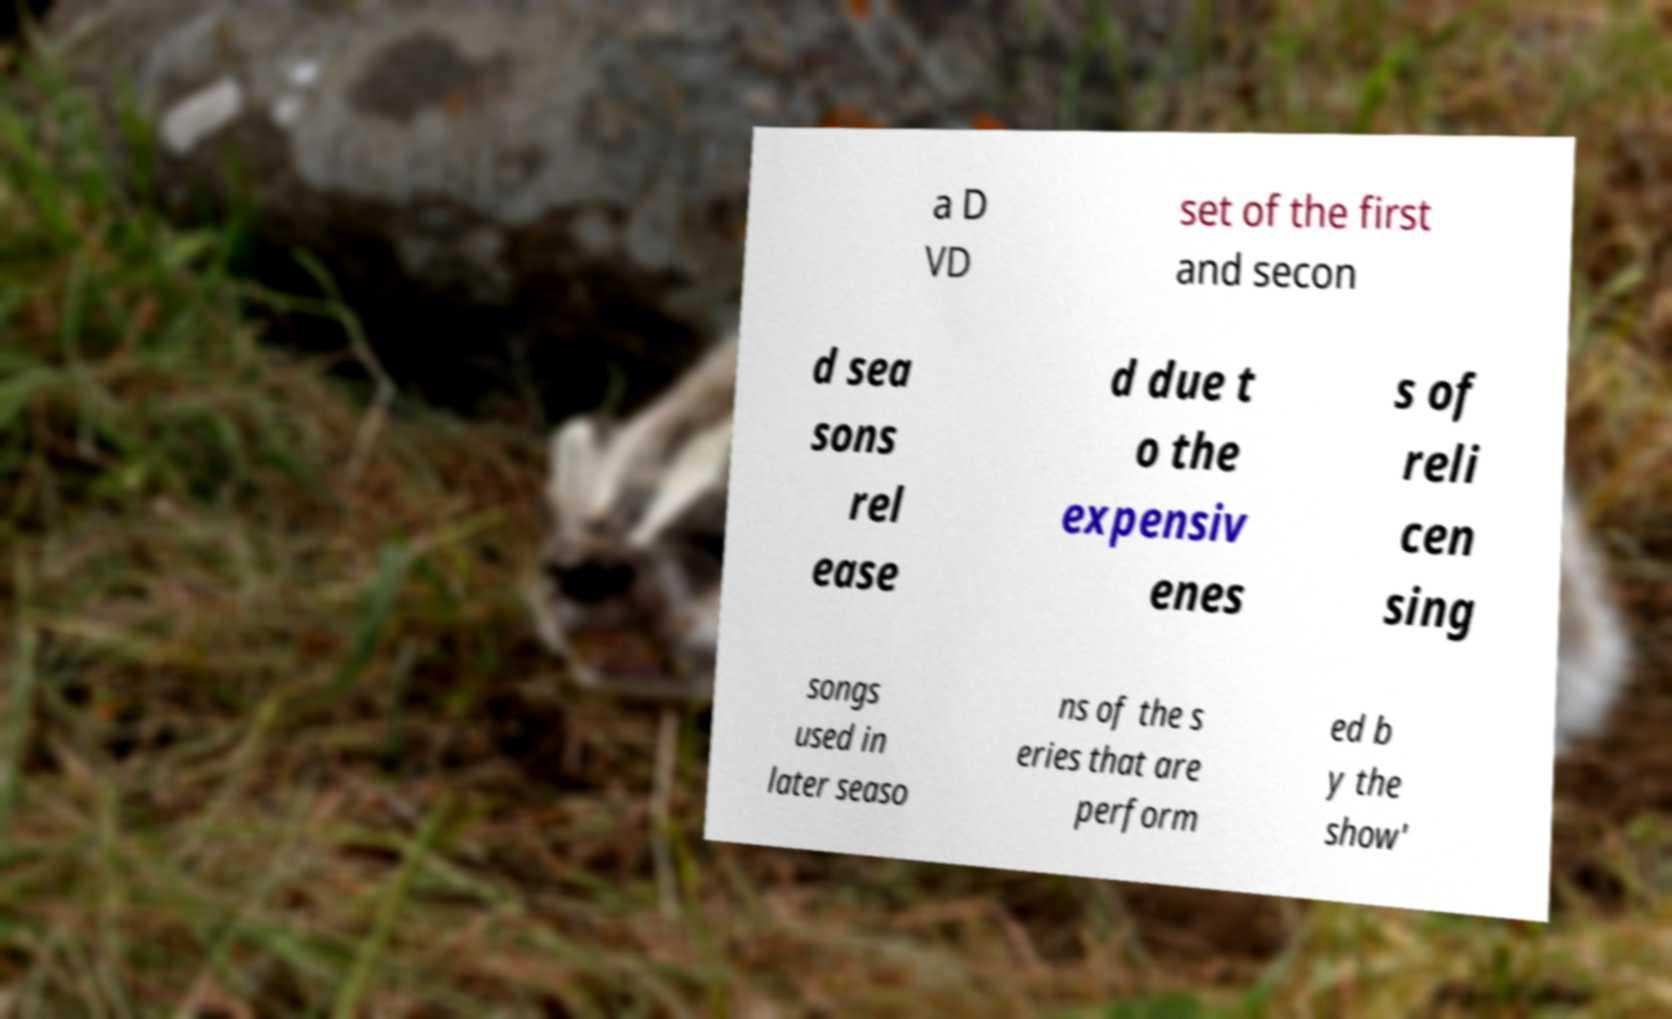What messages or text are displayed in this image? I need them in a readable, typed format. a D VD set of the first and secon d sea sons rel ease d due t o the expensiv enes s of reli cen sing songs used in later seaso ns of the s eries that are perform ed b y the show' 